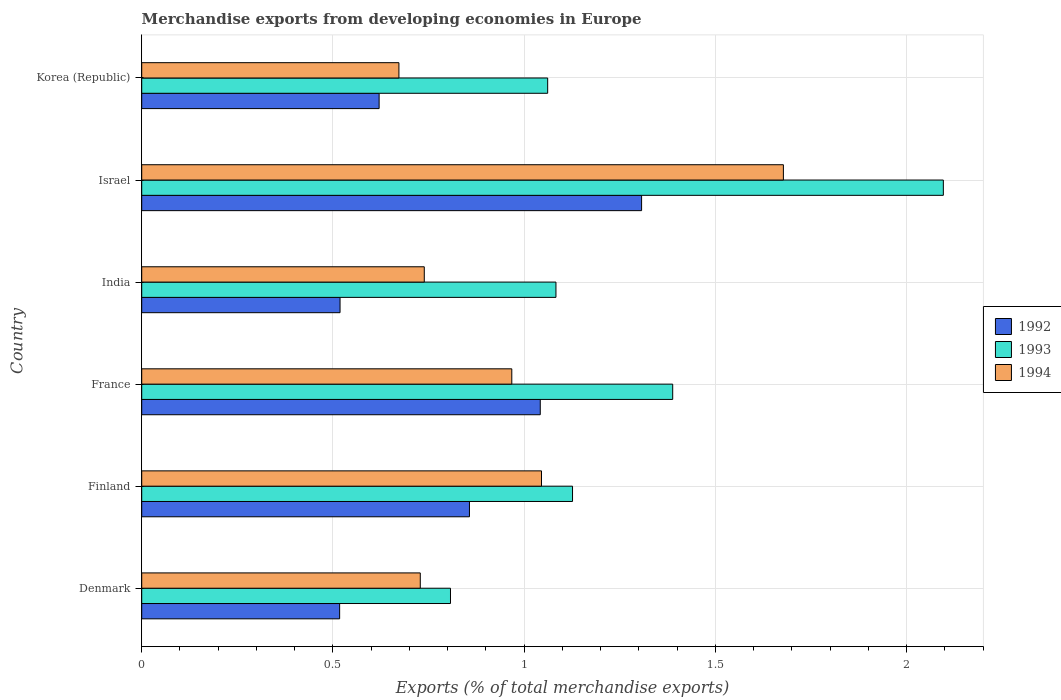Are the number of bars per tick equal to the number of legend labels?
Make the answer very short. Yes. Are the number of bars on each tick of the Y-axis equal?
Keep it short and to the point. Yes. How many bars are there on the 2nd tick from the top?
Keep it short and to the point. 3. What is the label of the 4th group of bars from the top?
Your answer should be very brief. France. What is the percentage of total merchandise exports in 1993 in Korea (Republic)?
Ensure brevity in your answer.  1.06. Across all countries, what is the maximum percentage of total merchandise exports in 1994?
Ensure brevity in your answer.  1.68. Across all countries, what is the minimum percentage of total merchandise exports in 1992?
Your response must be concise. 0.52. In which country was the percentage of total merchandise exports in 1994 maximum?
Keep it short and to the point. Israel. What is the total percentage of total merchandise exports in 1993 in the graph?
Offer a terse response. 7.56. What is the difference between the percentage of total merchandise exports in 1992 in Finland and that in India?
Keep it short and to the point. 0.34. What is the difference between the percentage of total merchandise exports in 1994 in Finland and the percentage of total merchandise exports in 1992 in Korea (Republic)?
Provide a short and direct response. 0.42. What is the average percentage of total merchandise exports in 1992 per country?
Offer a terse response. 0.81. What is the difference between the percentage of total merchandise exports in 1994 and percentage of total merchandise exports in 1992 in Korea (Republic)?
Offer a very short reply. 0.05. In how many countries, is the percentage of total merchandise exports in 1993 greater than 0.30000000000000004 %?
Keep it short and to the point. 6. What is the ratio of the percentage of total merchandise exports in 1992 in Denmark to that in Korea (Republic)?
Provide a succinct answer. 0.83. Is the percentage of total merchandise exports in 1992 in Denmark less than that in Korea (Republic)?
Make the answer very short. Yes. What is the difference between the highest and the second highest percentage of total merchandise exports in 1994?
Offer a terse response. 0.63. What is the difference between the highest and the lowest percentage of total merchandise exports in 1994?
Provide a succinct answer. 1.01. In how many countries, is the percentage of total merchandise exports in 1993 greater than the average percentage of total merchandise exports in 1993 taken over all countries?
Your answer should be compact. 2. What does the 3rd bar from the top in Korea (Republic) represents?
Offer a very short reply. 1992. Is it the case that in every country, the sum of the percentage of total merchandise exports in 1994 and percentage of total merchandise exports in 1992 is greater than the percentage of total merchandise exports in 1993?
Your answer should be compact. Yes. How many bars are there?
Provide a succinct answer. 18. Does the graph contain any zero values?
Provide a succinct answer. No. Does the graph contain grids?
Ensure brevity in your answer.  Yes. Where does the legend appear in the graph?
Give a very brief answer. Center right. How are the legend labels stacked?
Keep it short and to the point. Vertical. What is the title of the graph?
Your answer should be compact. Merchandise exports from developing economies in Europe. What is the label or title of the X-axis?
Ensure brevity in your answer.  Exports (% of total merchandise exports). What is the Exports (% of total merchandise exports) of 1992 in Denmark?
Your answer should be very brief. 0.52. What is the Exports (% of total merchandise exports) of 1993 in Denmark?
Ensure brevity in your answer.  0.81. What is the Exports (% of total merchandise exports) in 1994 in Denmark?
Your answer should be very brief. 0.73. What is the Exports (% of total merchandise exports) in 1992 in Finland?
Your answer should be compact. 0.86. What is the Exports (% of total merchandise exports) in 1993 in Finland?
Ensure brevity in your answer.  1.13. What is the Exports (% of total merchandise exports) of 1994 in Finland?
Offer a very short reply. 1.05. What is the Exports (% of total merchandise exports) in 1992 in France?
Ensure brevity in your answer.  1.04. What is the Exports (% of total merchandise exports) in 1993 in France?
Ensure brevity in your answer.  1.39. What is the Exports (% of total merchandise exports) in 1994 in France?
Provide a short and direct response. 0.97. What is the Exports (% of total merchandise exports) in 1992 in India?
Ensure brevity in your answer.  0.52. What is the Exports (% of total merchandise exports) of 1993 in India?
Keep it short and to the point. 1.08. What is the Exports (% of total merchandise exports) of 1994 in India?
Keep it short and to the point. 0.74. What is the Exports (% of total merchandise exports) of 1992 in Israel?
Give a very brief answer. 1.31. What is the Exports (% of total merchandise exports) in 1993 in Israel?
Offer a very short reply. 2.1. What is the Exports (% of total merchandise exports) of 1994 in Israel?
Keep it short and to the point. 1.68. What is the Exports (% of total merchandise exports) in 1992 in Korea (Republic)?
Offer a very short reply. 0.62. What is the Exports (% of total merchandise exports) of 1993 in Korea (Republic)?
Provide a short and direct response. 1.06. What is the Exports (% of total merchandise exports) of 1994 in Korea (Republic)?
Your response must be concise. 0.67. Across all countries, what is the maximum Exports (% of total merchandise exports) in 1992?
Provide a short and direct response. 1.31. Across all countries, what is the maximum Exports (% of total merchandise exports) of 1993?
Offer a terse response. 2.1. Across all countries, what is the maximum Exports (% of total merchandise exports) in 1994?
Provide a short and direct response. 1.68. Across all countries, what is the minimum Exports (% of total merchandise exports) of 1992?
Your response must be concise. 0.52. Across all countries, what is the minimum Exports (% of total merchandise exports) of 1993?
Your answer should be compact. 0.81. Across all countries, what is the minimum Exports (% of total merchandise exports) of 1994?
Ensure brevity in your answer.  0.67. What is the total Exports (% of total merchandise exports) in 1992 in the graph?
Offer a terse response. 4.86. What is the total Exports (% of total merchandise exports) of 1993 in the graph?
Your answer should be compact. 7.56. What is the total Exports (% of total merchandise exports) of 1994 in the graph?
Your response must be concise. 5.83. What is the difference between the Exports (% of total merchandise exports) in 1992 in Denmark and that in Finland?
Make the answer very short. -0.34. What is the difference between the Exports (% of total merchandise exports) in 1993 in Denmark and that in Finland?
Make the answer very short. -0.32. What is the difference between the Exports (% of total merchandise exports) in 1994 in Denmark and that in Finland?
Offer a very short reply. -0.32. What is the difference between the Exports (% of total merchandise exports) in 1992 in Denmark and that in France?
Provide a short and direct response. -0.52. What is the difference between the Exports (% of total merchandise exports) of 1993 in Denmark and that in France?
Your answer should be very brief. -0.58. What is the difference between the Exports (% of total merchandise exports) of 1994 in Denmark and that in France?
Give a very brief answer. -0.24. What is the difference between the Exports (% of total merchandise exports) of 1992 in Denmark and that in India?
Your answer should be very brief. -0. What is the difference between the Exports (% of total merchandise exports) of 1993 in Denmark and that in India?
Your answer should be compact. -0.28. What is the difference between the Exports (% of total merchandise exports) of 1994 in Denmark and that in India?
Your answer should be compact. -0.01. What is the difference between the Exports (% of total merchandise exports) of 1992 in Denmark and that in Israel?
Your answer should be very brief. -0.79. What is the difference between the Exports (% of total merchandise exports) in 1993 in Denmark and that in Israel?
Offer a very short reply. -1.29. What is the difference between the Exports (% of total merchandise exports) of 1994 in Denmark and that in Israel?
Offer a very short reply. -0.95. What is the difference between the Exports (% of total merchandise exports) in 1992 in Denmark and that in Korea (Republic)?
Your answer should be very brief. -0.1. What is the difference between the Exports (% of total merchandise exports) in 1993 in Denmark and that in Korea (Republic)?
Your answer should be very brief. -0.25. What is the difference between the Exports (% of total merchandise exports) of 1994 in Denmark and that in Korea (Republic)?
Give a very brief answer. 0.06. What is the difference between the Exports (% of total merchandise exports) in 1992 in Finland and that in France?
Keep it short and to the point. -0.19. What is the difference between the Exports (% of total merchandise exports) in 1993 in Finland and that in France?
Offer a terse response. -0.26. What is the difference between the Exports (% of total merchandise exports) in 1994 in Finland and that in France?
Your answer should be very brief. 0.08. What is the difference between the Exports (% of total merchandise exports) of 1992 in Finland and that in India?
Keep it short and to the point. 0.34. What is the difference between the Exports (% of total merchandise exports) in 1993 in Finland and that in India?
Ensure brevity in your answer.  0.04. What is the difference between the Exports (% of total merchandise exports) in 1994 in Finland and that in India?
Your response must be concise. 0.31. What is the difference between the Exports (% of total merchandise exports) in 1992 in Finland and that in Israel?
Make the answer very short. -0.45. What is the difference between the Exports (% of total merchandise exports) in 1993 in Finland and that in Israel?
Ensure brevity in your answer.  -0.97. What is the difference between the Exports (% of total merchandise exports) in 1994 in Finland and that in Israel?
Your answer should be compact. -0.63. What is the difference between the Exports (% of total merchandise exports) of 1992 in Finland and that in Korea (Republic)?
Your response must be concise. 0.24. What is the difference between the Exports (% of total merchandise exports) of 1993 in Finland and that in Korea (Republic)?
Your answer should be very brief. 0.07. What is the difference between the Exports (% of total merchandise exports) in 1994 in Finland and that in Korea (Republic)?
Offer a very short reply. 0.37. What is the difference between the Exports (% of total merchandise exports) of 1992 in France and that in India?
Give a very brief answer. 0.52. What is the difference between the Exports (% of total merchandise exports) in 1993 in France and that in India?
Make the answer very short. 0.31. What is the difference between the Exports (% of total merchandise exports) of 1994 in France and that in India?
Ensure brevity in your answer.  0.23. What is the difference between the Exports (% of total merchandise exports) of 1992 in France and that in Israel?
Your answer should be compact. -0.26. What is the difference between the Exports (% of total merchandise exports) in 1993 in France and that in Israel?
Keep it short and to the point. -0.71. What is the difference between the Exports (% of total merchandise exports) of 1994 in France and that in Israel?
Offer a very short reply. -0.71. What is the difference between the Exports (% of total merchandise exports) in 1992 in France and that in Korea (Republic)?
Your answer should be very brief. 0.42. What is the difference between the Exports (% of total merchandise exports) in 1993 in France and that in Korea (Republic)?
Offer a terse response. 0.33. What is the difference between the Exports (% of total merchandise exports) of 1994 in France and that in Korea (Republic)?
Your response must be concise. 0.3. What is the difference between the Exports (% of total merchandise exports) in 1992 in India and that in Israel?
Ensure brevity in your answer.  -0.79. What is the difference between the Exports (% of total merchandise exports) of 1993 in India and that in Israel?
Ensure brevity in your answer.  -1.01. What is the difference between the Exports (% of total merchandise exports) in 1994 in India and that in Israel?
Keep it short and to the point. -0.94. What is the difference between the Exports (% of total merchandise exports) of 1992 in India and that in Korea (Republic)?
Offer a very short reply. -0.1. What is the difference between the Exports (% of total merchandise exports) of 1993 in India and that in Korea (Republic)?
Make the answer very short. 0.02. What is the difference between the Exports (% of total merchandise exports) in 1994 in India and that in Korea (Republic)?
Make the answer very short. 0.07. What is the difference between the Exports (% of total merchandise exports) in 1992 in Israel and that in Korea (Republic)?
Keep it short and to the point. 0.69. What is the difference between the Exports (% of total merchandise exports) of 1993 in Israel and that in Korea (Republic)?
Offer a terse response. 1.03. What is the difference between the Exports (% of total merchandise exports) in 1994 in Israel and that in Korea (Republic)?
Provide a succinct answer. 1.01. What is the difference between the Exports (% of total merchandise exports) of 1992 in Denmark and the Exports (% of total merchandise exports) of 1993 in Finland?
Your answer should be very brief. -0.61. What is the difference between the Exports (% of total merchandise exports) of 1992 in Denmark and the Exports (% of total merchandise exports) of 1994 in Finland?
Your answer should be very brief. -0.53. What is the difference between the Exports (% of total merchandise exports) in 1993 in Denmark and the Exports (% of total merchandise exports) in 1994 in Finland?
Make the answer very short. -0.24. What is the difference between the Exports (% of total merchandise exports) in 1992 in Denmark and the Exports (% of total merchandise exports) in 1993 in France?
Make the answer very short. -0.87. What is the difference between the Exports (% of total merchandise exports) in 1992 in Denmark and the Exports (% of total merchandise exports) in 1994 in France?
Your answer should be compact. -0.45. What is the difference between the Exports (% of total merchandise exports) of 1993 in Denmark and the Exports (% of total merchandise exports) of 1994 in France?
Your answer should be compact. -0.16. What is the difference between the Exports (% of total merchandise exports) in 1992 in Denmark and the Exports (% of total merchandise exports) in 1993 in India?
Your answer should be very brief. -0.57. What is the difference between the Exports (% of total merchandise exports) of 1992 in Denmark and the Exports (% of total merchandise exports) of 1994 in India?
Make the answer very short. -0.22. What is the difference between the Exports (% of total merchandise exports) in 1993 in Denmark and the Exports (% of total merchandise exports) in 1994 in India?
Ensure brevity in your answer.  0.07. What is the difference between the Exports (% of total merchandise exports) of 1992 in Denmark and the Exports (% of total merchandise exports) of 1993 in Israel?
Provide a succinct answer. -1.58. What is the difference between the Exports (% of total merchandise exports) of 1992 in Denmark and the Exports (% of total merchandise exports) of 1994 in Israel?
Ensure brevity in your answer.  -1.16. What is the difference between the Exports (% of total merchandise exports) in 1993 in Denmark and the Exports (% of total merchandise exports) in 1994 in Israel?
Offer a very short reply. -0.87. What is the difference between the Exports (% of total merchandise exports) in 1992 in Denmark and the Exports (% of total merchandise exports) in 1993 in Korea (Republic)?
Provide a succinct answer. -0.54. What is the difference between the Exports (% of total merchandise exports) in 1992 in Denmark and the Exports (% of total merchandise exports) in 1994 in Korea (Republic)?
Offer a very short reply. -0.15. What is the difference between the Exports (% of total merchandise exports) in 1993 in Denmark and the Exports (% of total merchandise exports) in 1994 in Korea (Republic)?
Keep it short and to the point. 0.13. What is the difference between the Exports (% of total merchandise exports) of 1992 in Finland and the Exports (% of total merchandise exports) of 1993 in France?
Make the answer very short. -0.53. What is the difference between the Exports (% of total merchandise exports) in 1992 in Finland and the Exports (% of total merchandise exports) in 1994 in France?
Your response must be concise. -0.11. What is the difference between the Exports (% of total merchandise exports) of 1993 in Finland and the Exports (% of total merchandise exports) of 1994 in France?
Give a very brief answer. 0.16. What is the difference between the Exports (% of total merchandise exports) in 1992 in Finland and the Exports (% of total merchandise exports) in 1993 in India?
Provide a short and direct response. -0.23. What is the difference between the Exports (% of total merchandise exports) of 1992 in Finland and the Exports (% of total merchandise exports) of 1994 in India?
Make the answer very short. 0.12. What is the difference between the Exports (% of total merchandise exports) in 1993 in Finland and the Exports (% of total merchandise exports) in 1994 in India?
Ensure brevity in your answer.  0.39. What is the difference between the Exports (% of total merchandise exports) of 1992 in Finland and the Exports (% of total merchandise exports) of 1993 in Israel?
Make the answer very short. -1.24. What is the difference between the Exports (% of total merchandise exports) of 1992 in Finland and the Exports (% of total merchandise exports) of 1994 in Israel?
Your answer should be compact. -0.82. What is the difference between the Exports (% of total merchandise exports) in 1993 in Finland and the Exports (% of total merchandise exports) in 1994 in Israel?
Your answer should be compact. -0.55. What is the difference between the Exports (% of total merchandise exports) in 1992 in Finland and the Exports (% of total merchandise exports) in 1993 in Korea (Republic)?
Make the answer very short. -0.2. What is the difference between the Exports (% of total merchandise exports) of 1992 in Finland and the Exports (% of total merchandise exports) of 1994 in Korea (Republic)?
Offer a terse response. 0.18. What is the difference between the Exports (% of total merchandise exports) in 1993 in Finland and the Exports (% of total merchandise exports) in 1994 in Korea (Republic)?
Your answer should be compact. 0.45. What is the difference between the Exports (% of total merchandise exports) of 1992 in France and the Exports (% of total merchandise exports) of 1993 in India?
Ensure brevity in your answer.  -0.04. What is the difference between the Exports (% of total merchandise exports) in 1992 in France and the Exports (% of total merchandise exports) in 1994 in India?
Your answer should be compact. 0.3. What is the difference between the Exports (% of total merchandise exports) in 1993 in France and the Exports (% of total merchandise exports) in 1994 in India?
Offer a very short reply. 0.65. What is the difference between the Exports (% of total merchandise exports) in 1992 in France and the Exports (% of total merchandise exports) in 1993 in Israel?
Ensure brevity in your answer.  -1.05. What is the difference between the Exports (% of total merchandise exports) in 1992 in France and the Exports (% of total merchandise exports) in 1994 in Israel?
Ensure brevity in your answer.  -0.64. What is the difference between the Exports (% of total merchandise exports) of 1993 in France and the Exports (% of total merchandise exports) of 1994 in Israel?
Give a very brief answer. -0.29. What is the difference between the Exports (% of total merchandise exports) of 1992 in France and the Exports (% of total merchandise exports) of 1993 in Korea (Republic)?
Give a very brief answer. -0.02. What is the difference between the Exports (% of total merchandise exports) in 1992 in France and the Exports (% of total merchandise exports) in 1994 in Korea (Republic)?
Your response must be concise. 0.37. What is the difference between the Exports (% of total merchandise exports) in 1993 in France and the Exports (% of total merchandise exports) in 1994 in Korea (Republic)?
Keep it short and to the point. 0.72. What is the difference between the Exports (% of total merchandise exports) in 1992 in India and the Exports (% of total merchandise exports) in 1993 in Israel?
Your answer should be very brief. -1.58. What is the difference between the Exports (% of total merchandise exports) in 1992 in India and the Exports (% of total merchandise exports) in 1994 in Israel?
Your response must be concise. -1.16. What is the difference between the Exports (% of total merchandise exports) of 1993 in India and the Exports (% of total merchandise exports) of 1994 in Israel?
Offer a very short reply. -0.59. What is the difference between the Exports (% of total merchandise exports) in 1992 in India and the Exports (% of total merchandise exports) in 1993 in Korea (Republic)?
Make the answer very short. -0.54. What is the difference between the Exports (% of total merchandise exports) of 1992 in India and the Exports (% of total merchandise exports) of 1994 in Korea (Republic)?
Keep it short and to the point. -0.15. What is the difference between the Exports (% of total merchandise exports) in 1993 in India and the Exports (% of total merchandise exports) in 1994 in Korea (Republic)?
Ensure brevity in your answer.  0.41. What is the difference between the Exports (% of total merchandise exports) of 1992 in Israel and the Exports (% of total merchandise exports) of 1993 in Korea (Republic)?
Make the answer very short. 0.25. What is the difference between the Exports (% of total merchandise exports) of 1992 in Israel and the Exports (% of total merchandise exports) of 1994 in Korea (Republic)?
Make the answer very short. 0.63. What is the difference between the Exports (% of total merchandise exports) in 1993 in Israel and the Exports (% of total merchandise exports) in 1994 in Korea (Republic)?
Ensure brevity in your answer.  1.42. What is the average Exports (% of total merchandise exports) in 1992 per country?
Offer a terse response. 0.81. What is the average Exports (% of total merchandise exports) in 1993 per country?
Offer a terse response. 1.26. What is the average Exports (% of total merchandise exports) in 1994 per country?
Your response must be concise. 0.97. What is the difference between the Exports (% of total merchandise exports) in 1992 and Exports (% of total merchandise exports) in 1993 in Denmark?
Give a very brief answer. -0.29. What is the difference between the Exports (% of total merchandise exports) of 1992 and Exports (% of total merchandise exports) of 1994 in Denmark?
Your response must be concise. -0.21. What is the difference between the Exports (% of total merchandise exports) of 1993 and Exports (% of total merchandise exports) of 1994 in Denmark?
Your response must be concise. 0.08. What is the difference between the Exports (% of total merchandise exports) in 1992 and Exports (% of total merchandise exports) in 1993 in Finland?
Your answer should be very brief. -0.27. What is the difference between the Exports (% of total merchandise exports) in 1992 and Exports (% of total merchandise exports) in 1994 in Finland?
Provide a short and direct response. -0.19. What is the difference between the Exports (% of total merchandise exports) of 1993 and Exports (% of total merchandise exports) of 1994 in Finland?
Provide a short and direct response. 0.08. What is the difference between the Exports (% of total merchandise exports) of 1992 and Exports (% of total merchandise exports) of 1993 in France?
Provide a succinct answer. -0.35. What is the difference between the Exports (% of total merchandise exports) in 1992 and Exports (% of total merchandise exports) in 1994 in France?
Keep it short and to the point. 0.07. What is the difference between the Exports (% of total merchandise exports) of 1993 and Exports (% of total merchandise exports) of 1994 in France?
Provide a succinct answer. 0.42. What is the difference between the Exports (% of total merchandise exports) of 1992 and Exports (% of total merchandise exports) of 1993 in India?
Your response must be concise. -0.56. What is the difference between the Exports (% of total merchandise exports) of 1992 and Exports (% of total merchandise exports) of 1994 in India?
Your answer should be very brief. -0.22. What is the difference between the Exports (% of total merchandise exports) in 1993 and Exports (% of total merchandise exports) in 1994 in India?
Offer a very short reply. 0.34. What is the difference between the Exports (% of total merchandise exports) of 1992 and Exports (% of total merchandise exports) of 1993 in Israel?
Offer a very short reply. -0.79. What is the difference between the Exports (% of total merchandise exports) in 1992 and Exports (% of total merchandise exports) in 1994 in Israel?
Make the answer very short. -0.37. What is the difference between the Exports (% of total merchandise exports) in 1993 and Exports (% of total merchandise exports) in 1994 in Israel?
Your answer should be compact. 0.42. What is the difference between the Exports (% of total merchandise exports) of 1992 and Exports (% of total merchandise exports) of 1993 in Korea (Republic)?
Give a very brief answer. -0.44. What is the difference between the Exports (% of total merchandise exports) in 1992 and Exports (% of total merchandise exports) in 1994 in Korea (Republic)?
Offer a terse response. -0.05. What is the difference between the Exports (% of total merchandise exports) in 1993 and Exports (% of total merchandise exports) in 1994 in Korea (Republic)?
Give a very brief answer. 0.39. What is the ratio of the Exports (% of total merchandise exports) of 1992 in Denmark to that in Finland?
Give a very brief answer. 0.6. What is the ratio of the Exports (% of total merchandise exports) in 1993 in Denmark to that in Finland?
Offer a very short reply. 0.72. What is the ratio of the Exports (% of total merchandise exports) in 1994 in Denmark to that in Finland?
Ensure brevity in your answer.  0.7. What is the ratio of the Exports (% of total merchandise exports) in 1992 in Denmark to that in France?
Provide a succinct answer. 0.5. What is the ratio of the Exports (% of total merchandise exports) of 1993 in Denmark to that in France?
Your answer should be very brief. 0.58. What is the ratio of the Exports (% of total merchandise exports) in 1994 in Denmark to that in France?
Your answer should be very brief. 0.75. What is the ratio of the Exports (% of total merchandise exports) in 1993 in Denmark to that in India?
Your answer should be compact. 0.75. What is the ratio of the Exports (% of total merchandise exports) in 1994 in Denmark to that in India?
Your answer should be compact. 0.99. What is the ratio of the Exports (% of total merchandise exports) in 1992 in Denmark to that in Israel?
Provide a succinct answer. 0.4. What is the ratio of the Exports (% of total merchandise exports) of 1993 in Denmark to that in Israel?
Provide a short and direct response. 0.39. What is the ratio of the Exports (% of total merchandise exports) in 1994 in Denmark to that in Israel?
Keep it short and to the point. 0.43. What is the ratio of the Exports (% of total merchandise exports) of 1992 in Denmark to that in Korea (Republic)?
Keep it short and to the point. 0.83. What is the ratio of the Exports (% of total merchandise exports) in 1993 in Denmark to that in Korea (Republic)?
Offer a very short reply. 0.76. What is the ratio of the Exports (% of total merchandise exports) of 1994 in Denmark to that in Korea (Republic)?
Give a very brief answer. 1.08. What is the ratio of the Exports (% of total merchandise exports) of 1992 in Finland to that in France?
Offer a terse response. 0.82. What is the ratio of the Exports (% of total merchandise exports) in 1993 in Finland to that in France?
Provide a succinct answer. 0.81. What is the ratio of the Exports (% of total merchandise exports) in 1994 in Finland to that in France?
Give a very brief answer. 1.08. What is the ratio of the Exports (% of total merchandise exports) of 1992 in Finland to that in India?
Provide a short and direct response. 1.65. What is the ratio of the Exports (% of total merchandise exports) in 1993 in Finland to that in India?
Offer a very short reply. 1.04. What is the ratio of the Exports (% of total merchandise exports) in 1994 in Finland to that in India?
Give a very brief answer. 1.41. What is the ratio of the Exports (% of total merchandise exports) in 1992 in Finland to that in Israel?
Offer a terse response. 0.66. What is the ratio of the Exports (% of total merchandise exports) of 1993 in Finland to that in Israel?
Offer a terse response. 0.54. What is the ratio of the Exports (% of total merchandise exports) in 1994 in Finland to that in Israel?
Your answer should be very brief. 0.62. What is the ratio of the Exports (% of total merchandise exports) of 1992 in Finland to that in Korea (Republic)?
Your response must be concise. 1.38. What is the ratio of the Exports (% of total merchandise exports) of 1993 in Finland to that in Korea (Republic)?
Your answer should be compact. 1.06. What is the ratio of the Exports (% of total merchandise exports) in 1994 in Finland to that in Korea (Republic)?
Provide a succinct answer. 1.55. What is the ratio of the Exports (% of total merchandise exports) in 1992 in France to that in India?
Make the answer very short. 2.01. What is the ratio of the Exports (% of total merchandise exports) of 1993 in France to that in India?
Offer a terse response. 1.28. What is the ratio of the Exports (% of total merchandise exports) in 1994 in France to that in India?
Provide a succinct answer. 1.31. What is the ratio of the Exports (% of total merchandise exports) of 1992 in France to that in Israel?
Give a very brief answer. 0.8. What is the ratio of the Exports (% of total merchandise exports) in 1993 in France to that in Israel?
Provide a succinct answer. 0.66. What is the ratio of the Exports (% of total merchandise exports) of 1994 in France to that in Israel?
Make the answer very short. 0.58. What is the ratio of the Exports (% of total merchandise exports) in 1992 in France to that in Korea (Republic)?
Provide a short and direct response. 1.68. What is the ratio of the Exports (% of total merchandise exports) in 1993 in France to that in Korea (Republic)?
Offer a terse response. 1.31. What is the ratio of the Exports (% of total merchandise exports) in 1994 in France to that in Korea (Republic)?
Give a very brief answer. 1.44. What is the ratio of the Exports (% of total merchandise exports) in 1992 in India to that in Israel?
Give a very brief answer. 0.4. What is the ratio of the Exports (% of total merchandise exports) in 1993 in India to that in Israel?
Your response must be concise. 0.52. What is the ratio of the Exports (% of total merchandise exports) in 1994 in India to that in Israel?
Provide a short and direct response. 0.44. What is the ratio of the Exports (% of total merchandise exports) of 1992 in India to that in Korea (Republic)?
Provide a short and direct response. 0.84. What is the ratio of the Exports (% of total merchandise exports) of 1993 in India to that in Korea (Republic)?
Your answer should be very brief. 1.02. What is the ratio of the Exports (% of total merchandise exports) in 1994 in India to that in Korea (Republic)?
Give a very brief answer. 1.1. What is the ratio of the Exports (% of total merchandise exports) of 1992 in Israel to that in Korea (Republic)?
Ensure brevity in your answer.  2.11. What is the ratio of the Exports (% of total merchandise exports) in 1993 in Israel to that in Korea (Republic)?
Your answer should be compact. 1.97. What is the ratio of the Exports (% of total merchandise exports) of 1994 in Israel to that in Korea (Republic)?
Give a very brief answer. 2.49. What is the difference between the highest and the second highest Exports (% of total merchandise exports) in 1992?
Provide a succinct answer. 0.26. What is the difference between the highest and the second highest Exports (% of total merchandise exports) of 1993?
Ensure brevity in your answer.  0.71. What is the difference between the highest and the second highest Exports (% of total merchandise exports) in 1994?
Keep it short and to the point. 0.63. What is the difference between the highest and the lowest Exports (% of total merchandise exports) of 1992?
Offer a terse response. 0.79. What is the difference between the highest and the lowest Exports (% of total merchandise exports) in 1993?
Make the answer very short. 1.29. What is the difference between the highest and the lowest Exports (% of total merchandise exports) of 1994?
Ensure brevity in your answer.  1.01. 